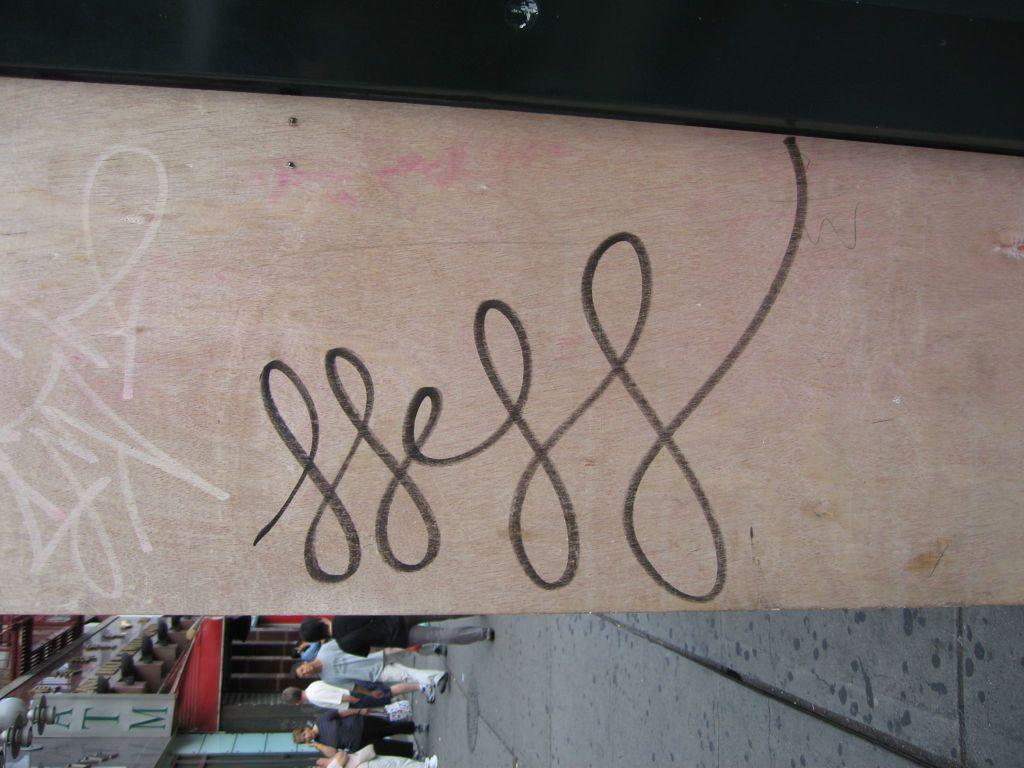What is the main object in the image? There is a wooden board in the image. What can be seen in the foreground of the image? There are people standing on the ground in the image. What is visible in the background of the image? There is a building visible in the background of the image. What is the purpose of the hoarding in the image? The hoarding has the word "ATM" written on it, indicating that it is advertising an ATM location. How does the tramp use the wooden board in the image? There is no tramp present in the image, and therefore no such interaction can be observed. 